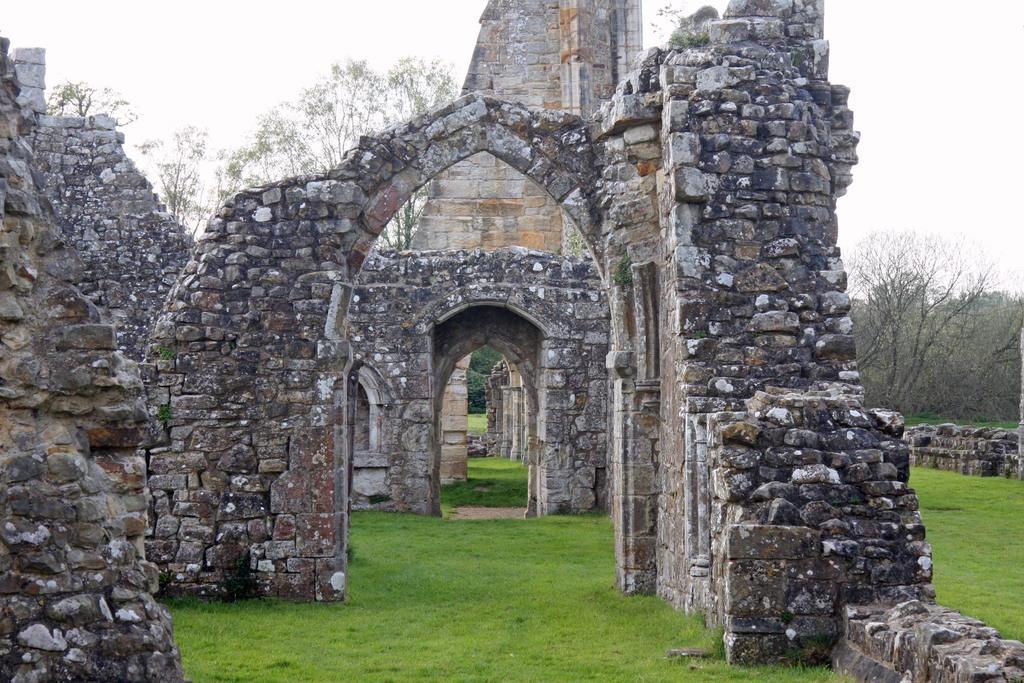In one or two sentences, can you explain what this image depicts? In this image I can see a fort. Background I can see few dried trees, grass in green color and sky in white color. 